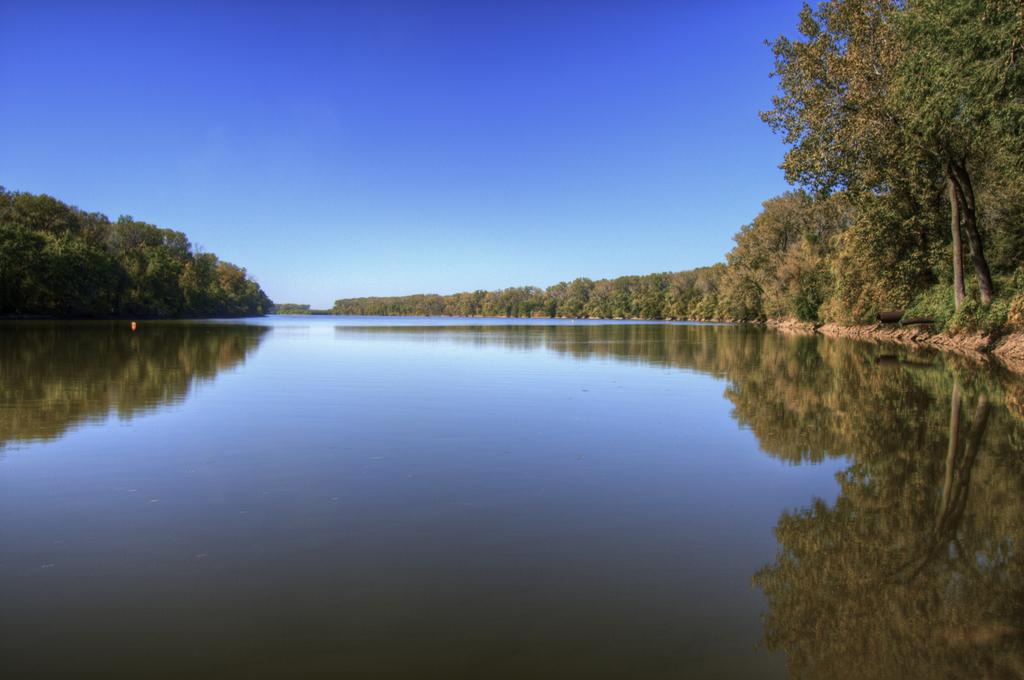What can be seen in the image? There is water visible in the image, along with trees. What is the condition of the sky in the image? The sky is clear in the background of the image. What type of toe is visible in the image? There are no toes present in the image; it features water and trees. What kind of impulse can be seen affecting the band in the image? There is no band present in the image, so it's not possible to determine any impulses affecting them. 